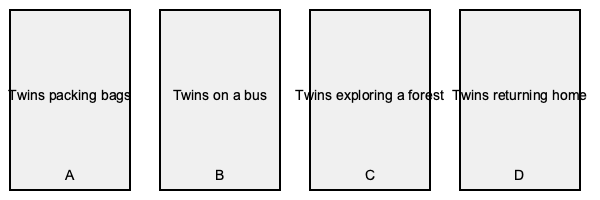Arrange the images A, B, C, and D in chronological order to create a coherent story timeline for the twins' adventure. What is the correct sequence? To create a chronological story timeline for the twins' adventure, we need to analyze each image and determine the logical sequence of events:

1. Image A shows the twins packing bags. This is typically the first step in any adventure, as characters prepare for their journey.

2. Image B depicts the twins on a bus. This logically follows the packing scene, as the twins are now embarking on their journey to their destination.

3. Image C illustrates the twins exploring a forest. This represents the main part of their adventure, which occurs after they've reached their destination.

4. Image D shows the twins returning home. This is clearly the final step in their adventure, as they complete their journey and come back.

Therefore, the chronological order of events in the twins' adventure would be:

1. Packing bags (A)
2. Traveling on a bus (B)
3. Exploring a forest (C)
4. Returning home (D)

This sequence creates a coherent narrative arc for a children's story about twin adventures, starting with preparation, followed by travel, the main adventure, and finally the return home.
Answer: A, B, C, D 